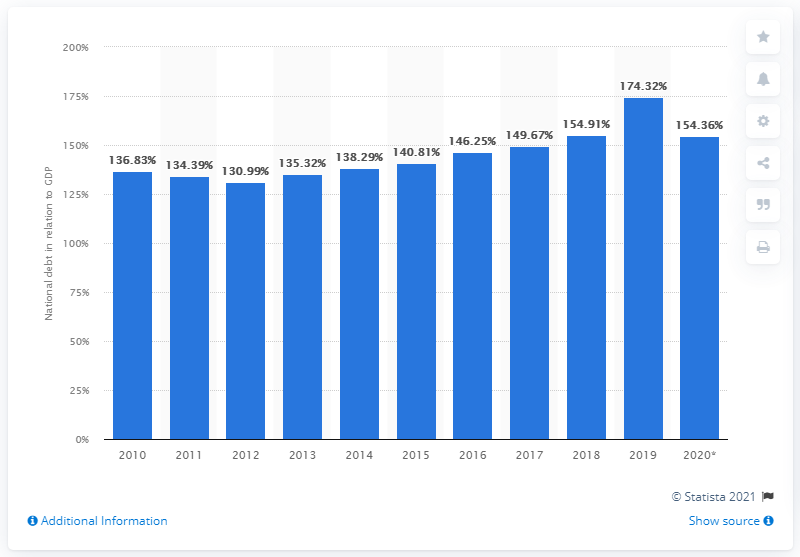Draw attention to some important aspects in this diagram. In 2018, the national debt of Lebanon accounted for approximately 154.36% of the country's Gross Domestic Product (GDP). 